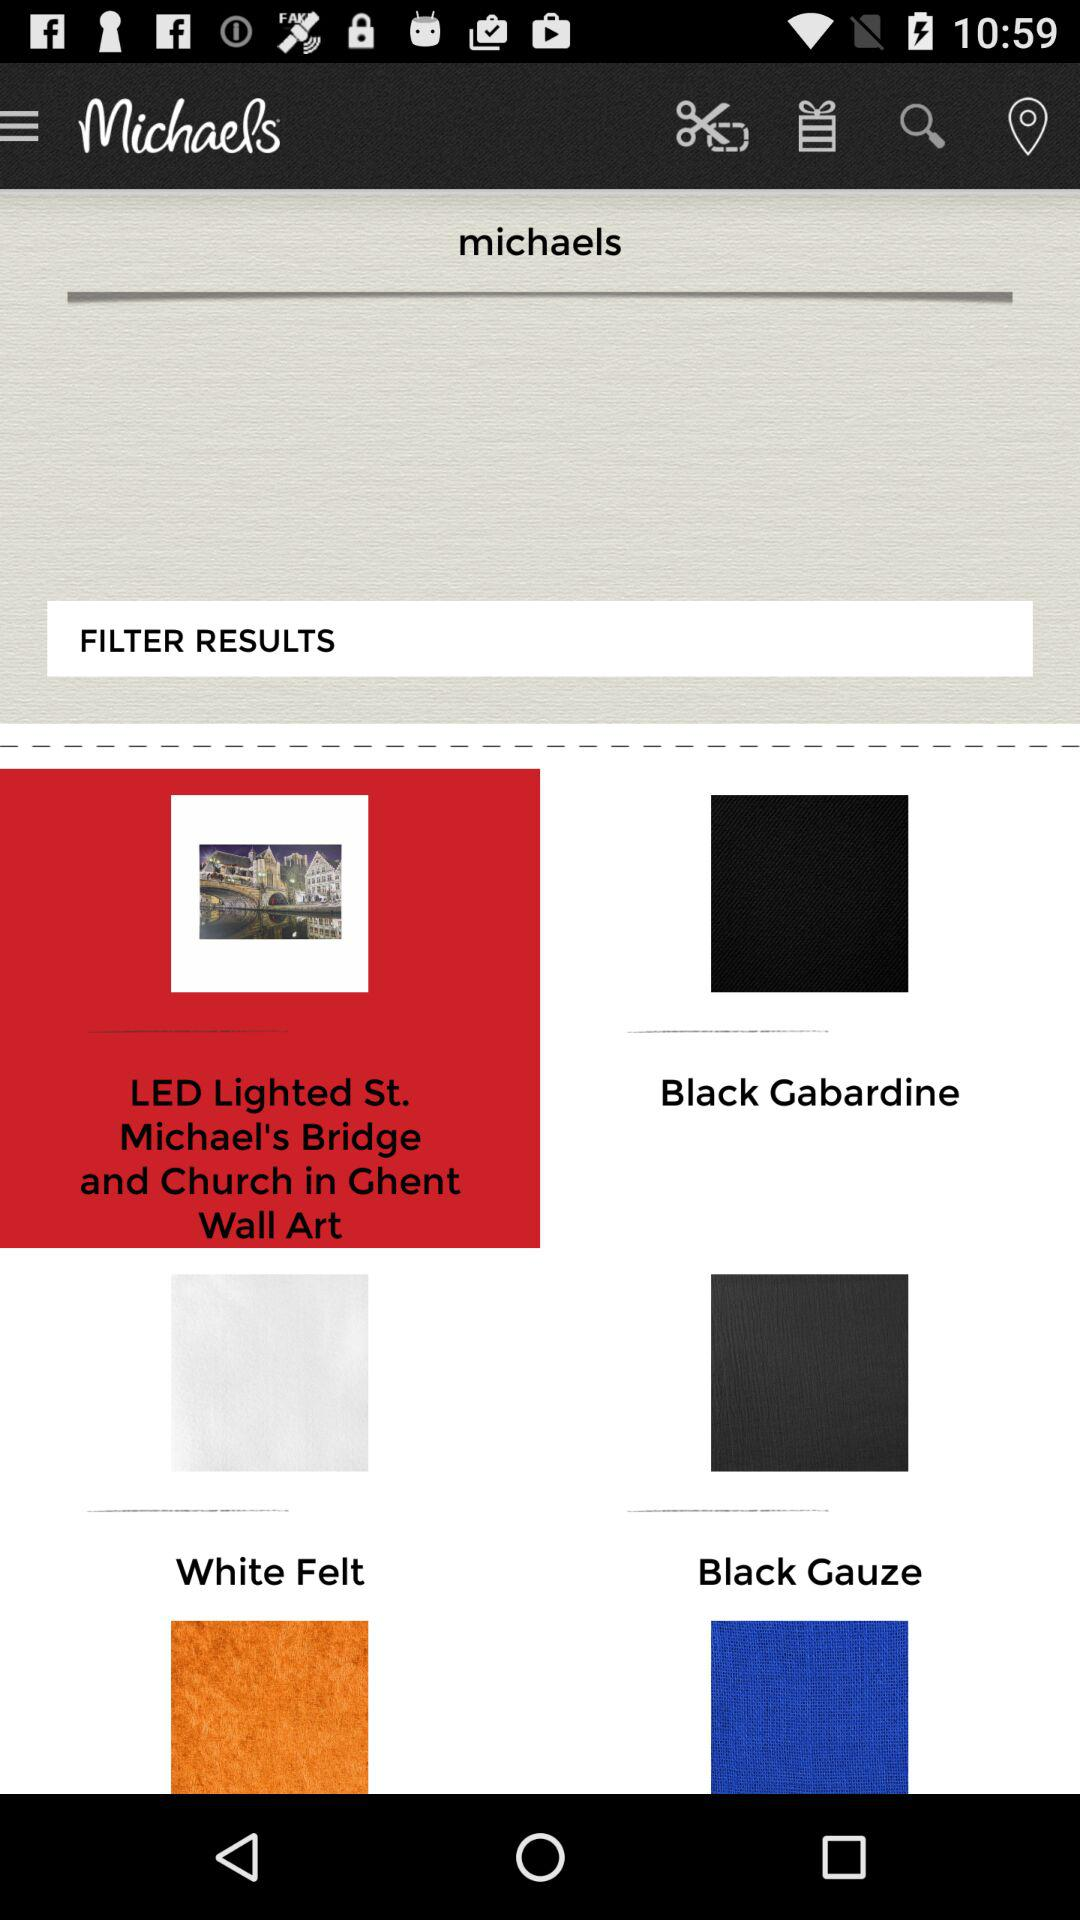What is the application name? The application name is "Michaels". 